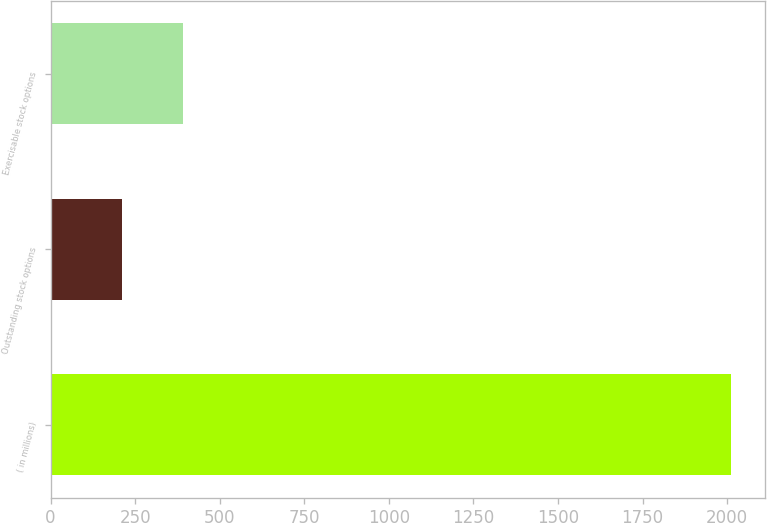Convert chart. <chart><loc_0><loc_0><loc_500><loc_500><bar_chart><fcel>( in millions)<fcel>Outstanding stock options<fcel>Exercisable stock options<nl><fcel>2011<fcel>211<fcel>391<nl></chart> 